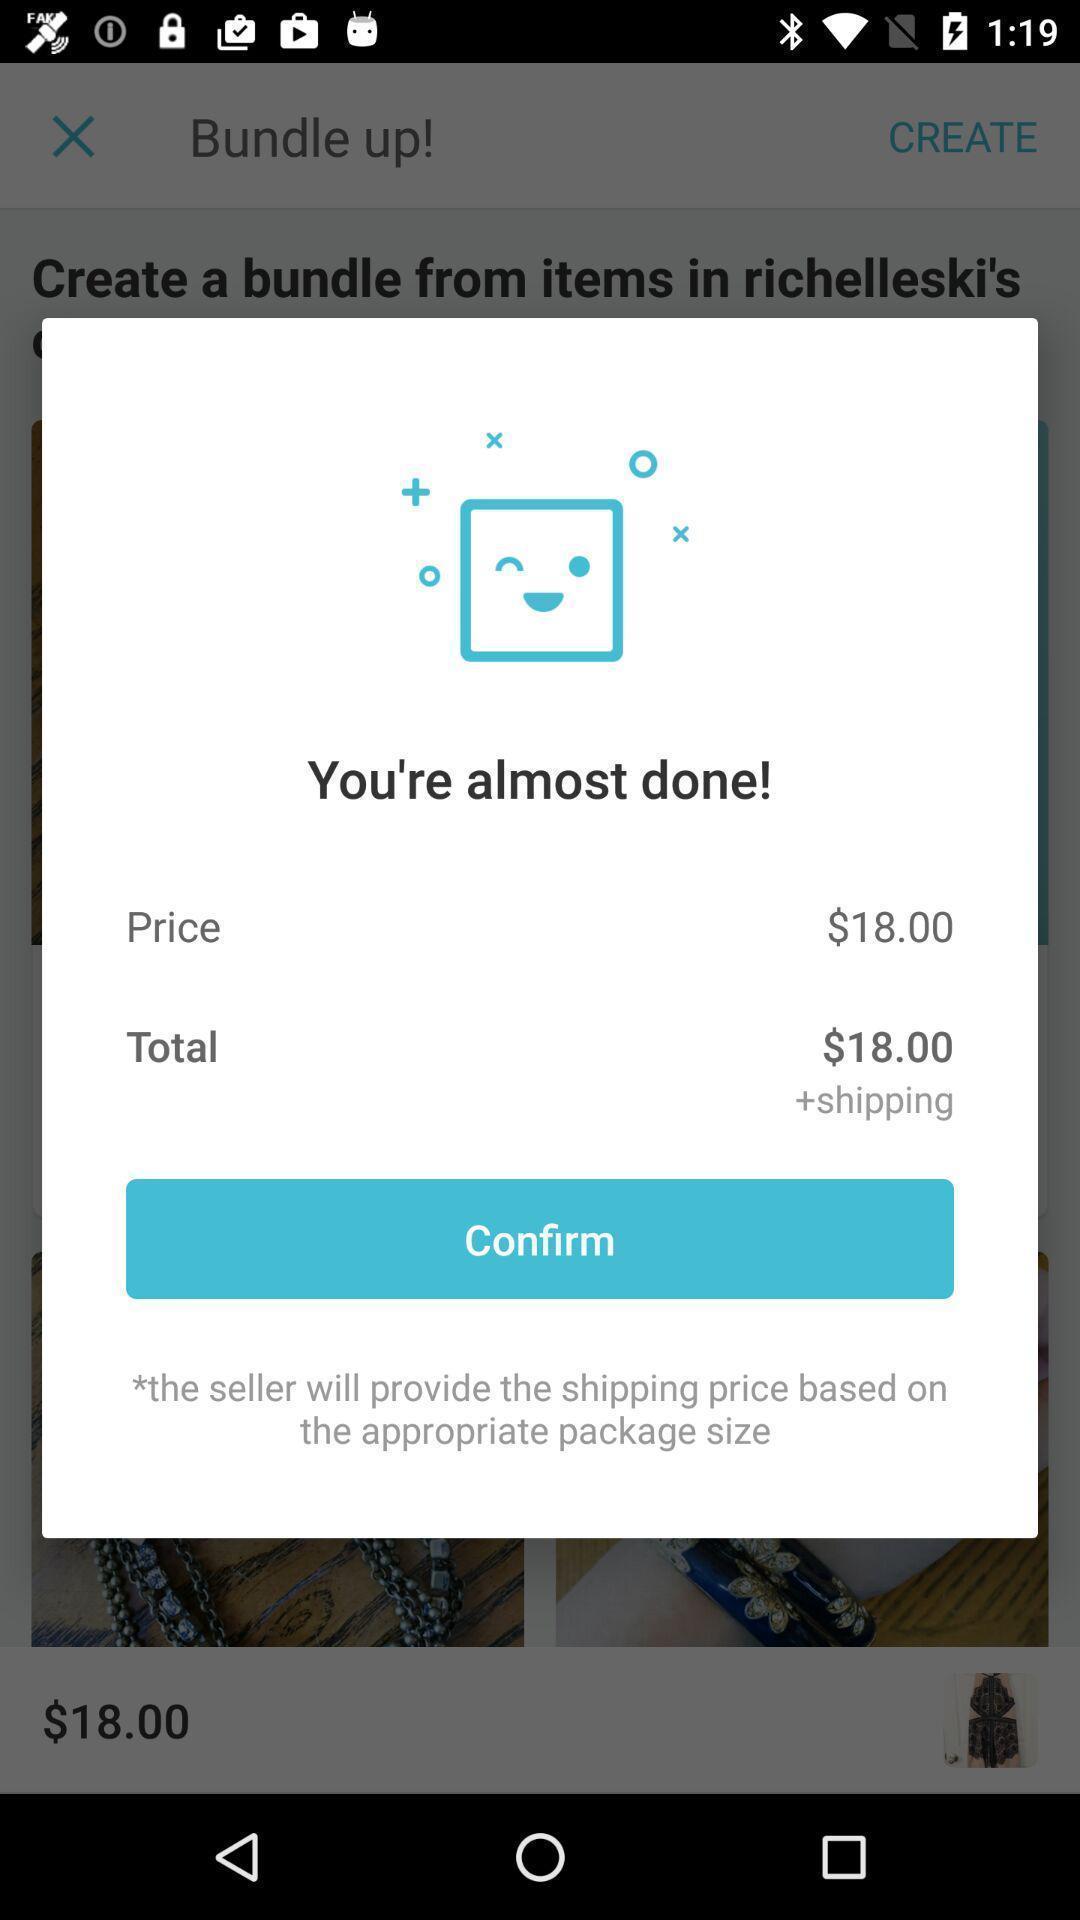Explain what's happening in this screen capture. Screen displaying confirmation message for payment. 